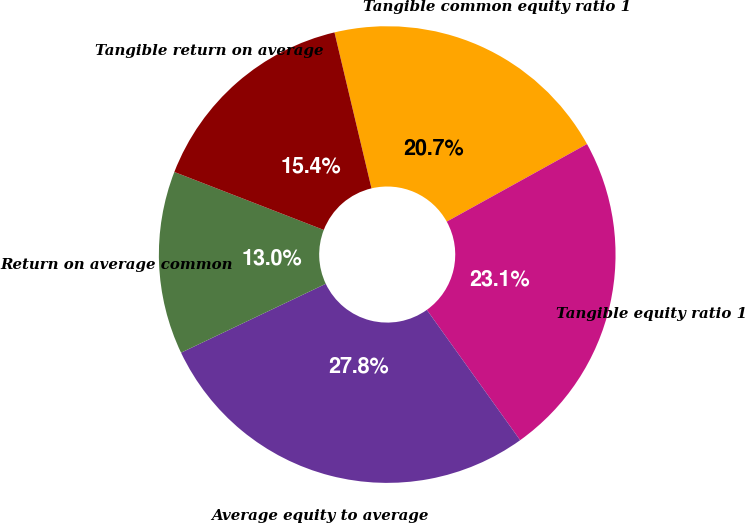Convert chart to OTSL. <chart><loc_0><loc_0><loc_500><loc_500><pie_chart><fcel>Tangible common equity ratio 1<fcel>Tangible equity ratio 1<fcel>Average equity to average<fcel>Return on average common<fcel>Tangible return on average<nl><fcel>20.67%<fcel>23.15%<fcel>27.82%<fcel>12.96%<fcel>15.4%<nl></chart> 